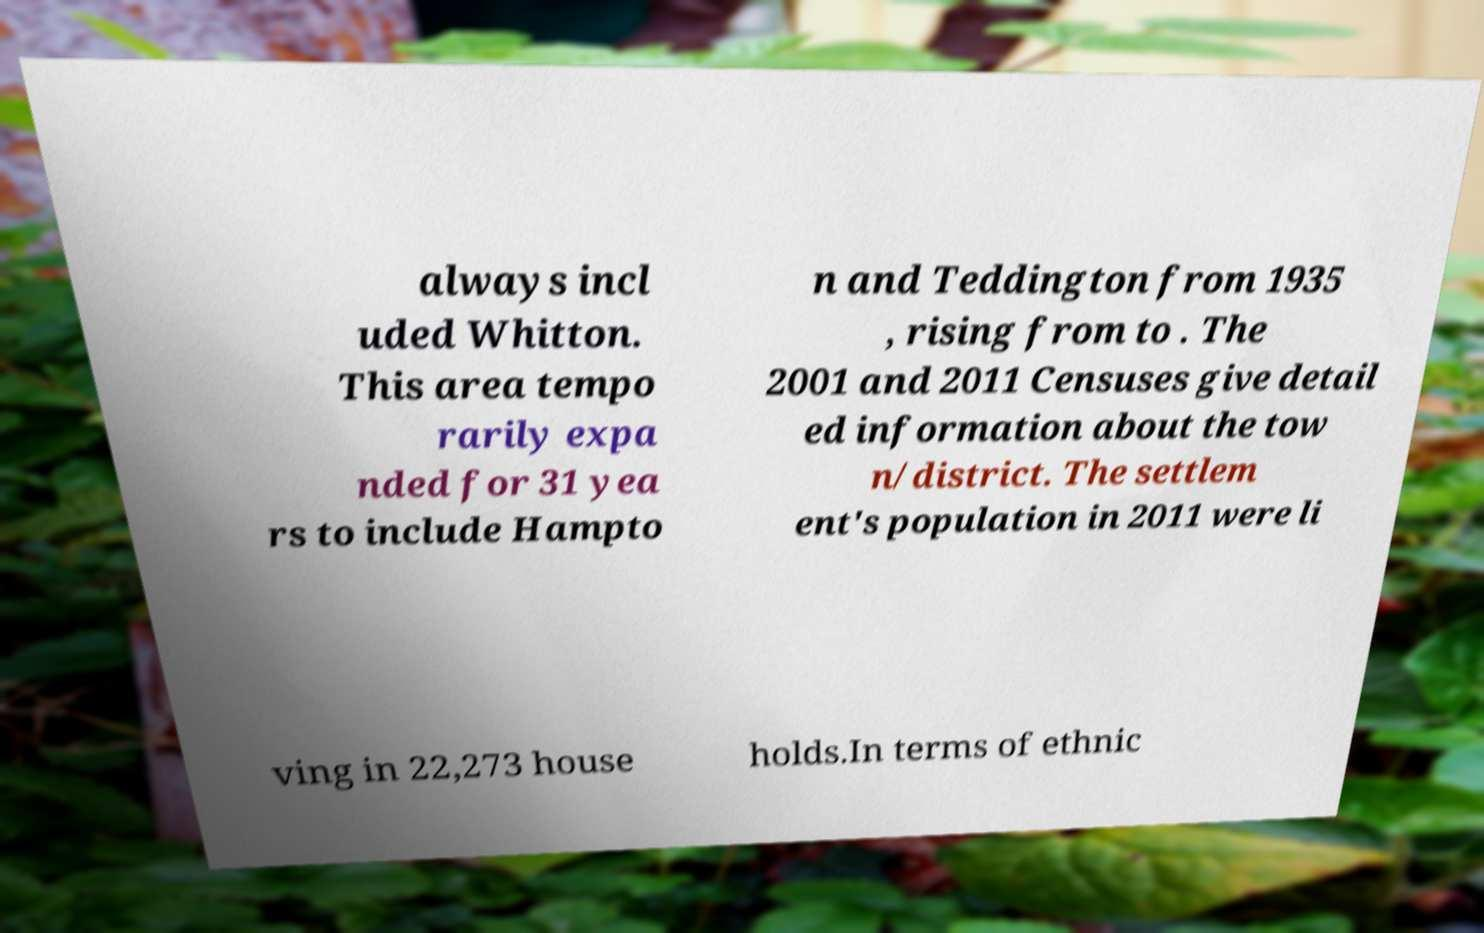Can you read and provide the text displayed in the image?This photo seems to have some interesting text. Can you extract and type it out for me? always incl uded Whitton. This area tempo rarily expa nded for 31 yea rs to include Hampto n and Teddington from 1935 , rising from to . The 2001 and 2011 Censuses give detail ed information about the tow n/district. The settlem ent's population in 2011 were li ving in 22,273 house holds.In terms of ethnic 